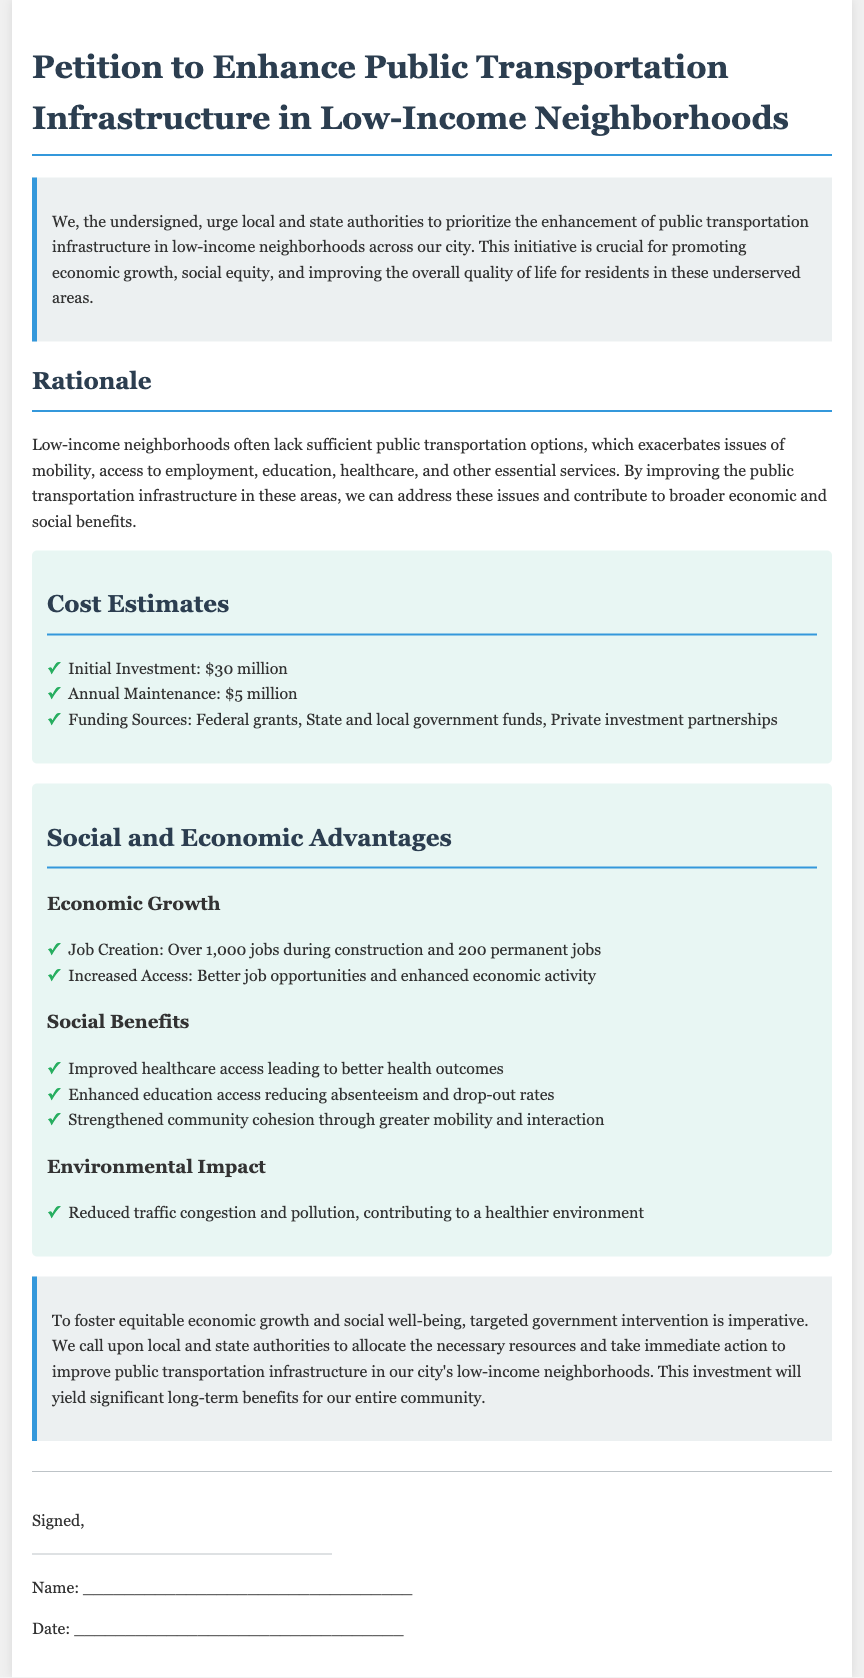What is the initial investment cost? The initial investment is explicitly stated in the document as the first cost estimate, which is $30 million.
Answer: $30 million How many permanent jobs are expected to be created? The number of permanent jobs created is listed under the economic growth section as 200 permanent jobs.
Answer: 200 What is the annual maintenance cost? The annual maintenance cost is provided in the cost estimates section, which states it is $5 million.
Answer: $5 million What is one of the funding sources mentioned? The document lists various funding sources, one of which is federal grants, identified in the cost estimates section.
Answer: Federal grants What type of access is expected to improve through better public transportation? Improved access to healthcare is one of the social benefits mentioned in the advantages section, indicating a specific area affected.
Answer: Healthcare What is the total job creation during construction? The total jobs created during construction is stated in the document as over 1,000 jobs.
Answer: Over 1,000 jobs What is one environmental impact expected from the project? The document highlights reduced traffic congestion and pollution as an expected environmental impact in the advantages section.
Answer: Reduced traffic congestion What is the purpose of the petition? The purpose of the petition is outlined in the introduction, which urges local and state authorities to enhance public transportation infrastructure in low-income neighborhoods.
Answer: Enhance public transportation infrastructure What immediate action is being requested from authorities? The conclusion urges authorities to allocate necessary resources for immediate action to improve public transportation.
Answer: Allocate necessary resources 